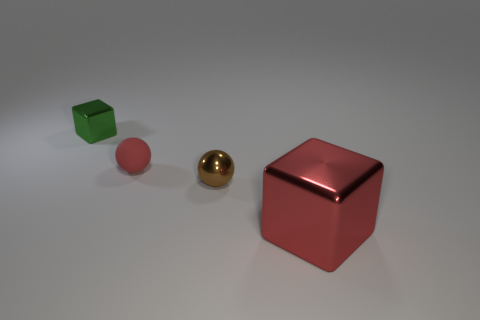Add 2 small blue shiny cylinders. How many objects exist? 6 Subtract 1 blocks. How many blocks are left? 1 Subtract all yellow blocks. Subtract all cyan cylinders. How many blocks are left? 2 Subtract all blue cylinders. How many red cubes are left? 1 Subtract all rubber things. Subtract all red blocks. How many objects are left? 2 Add 1 matte objects. How many matte objects are left? 2 Add 4 tiny red matte things. How many tiny red matte things exist? 5 Subtract all red cubes. How many cubes are left? 1 Subtract 0 green spheres. How many objects are left? 4 